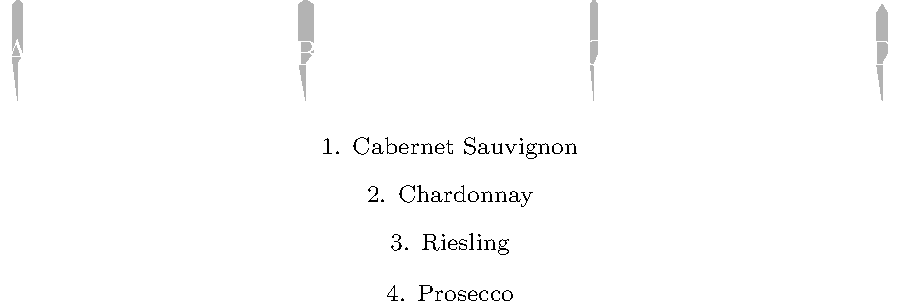As a wine enthusiast, match the silhouettes of wine bottles (A-D) with their corresponding wine types (1-4). Which combination is correct? Let's analyze each bottle shape and match it to the appropriate wine type:

1. Bottle A: This is a Bordeaux bottle, characterized by its straight sides and high shoulders. It's typically used for Cabernet Sauvignon, Merlot, and other Bordeaux-style wines. Therefore, A matches with 1 (Cabernet Sauvignon).

2. Bottle B: This is a Burgundy bottle, known for its wider base and gently sloping shoulders. It's commonly used for Chardonnay and Pinot Noir. In this case, B matches with 2 (Chardonnay).

3. Bottle C: This slender bottle is typical of Alsace and Mosel regions. It's often used for aromatic white wines like Riesling, Gewürztraminer, and Pinot Gris. Thus, C matches with 3 (Riesling).

4. Bottle D: This bottle has a wider base and more pronounced shoulders, typical of sparkling wine bottles. It's designed to withstand the pressure of carbonation. Prosecco, being a sparkling wine, would be bottled in this type. Therefore, D matches with 4 (Prosecco).

The correct combination is A1, B2, C3, D4.
Answer: A1, B2, C3, D4 